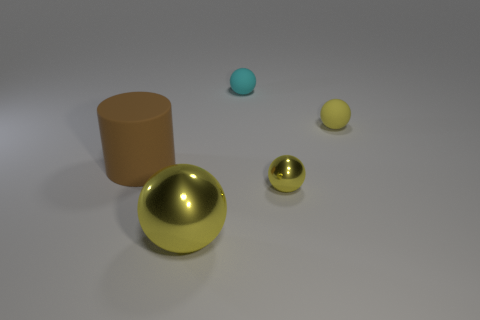Subtract all brown cubes. How many yellow balls are left? 3 Add 2 yellow metal blocks. How many objects exist? 7 Subtract all cylinders. How many objects are left? 4 Subtract 0 purple cylinders. How many objects are left? 5 Subtract all brown matte spheres. Subtract all rubber cylinders. How many objects are left? 4 Add 2 metal objects. How many metal objects are left? 4 Add 4 large rubber objects. How many large rubber objects exist? 5 